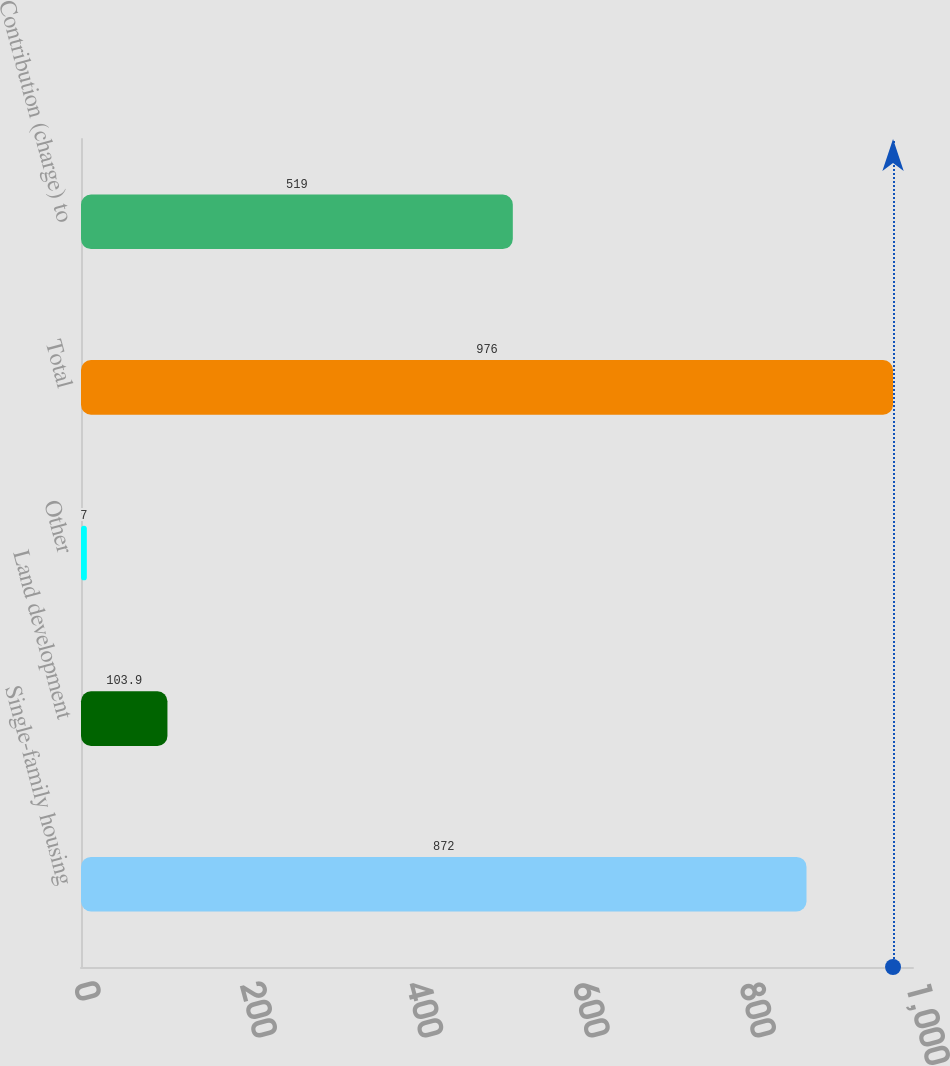Convert chart to OTSL. <chart><loc_0><loc_0><loc_500><loc_500><bar_chart><fcel>Single-family housing<fcel>Land development<fcel>Other<fcel>Total<fcel>Contribution (charge) to<nl><fcel>872<fcel>103.9<fcel>7<fcel>976<fcel>519<nl></chart> 